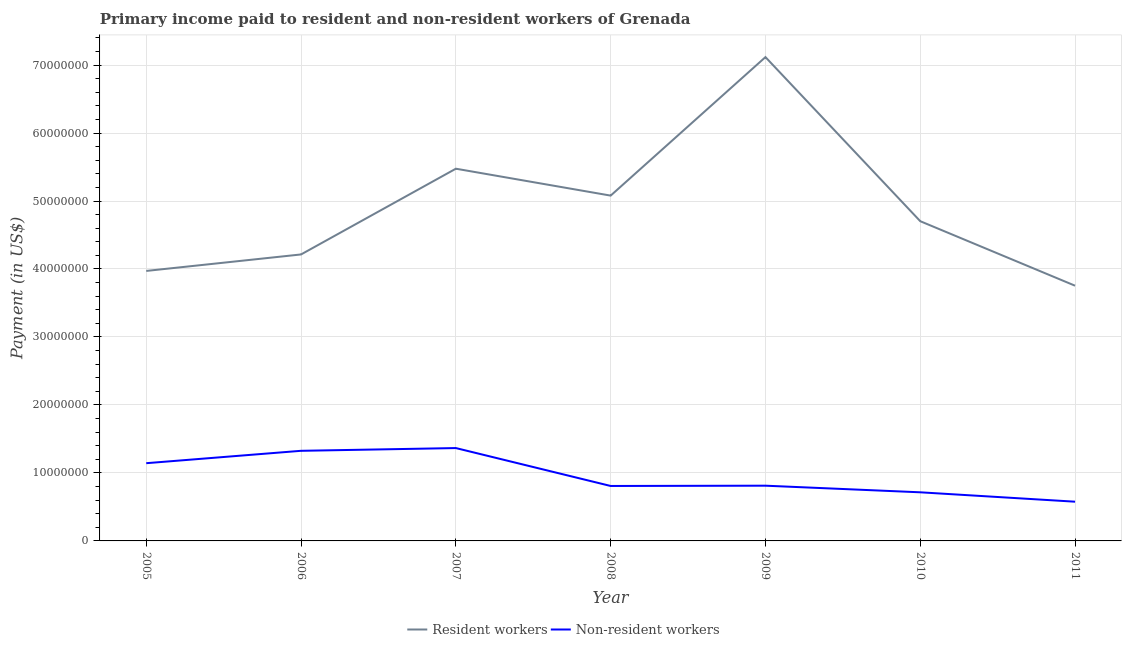Does the line corresponding to payment made to non-resident workers intersect with the line corresponding to payment made to resident workers?
Make the answer very short. No. Is the number of lines equal to the number of legend labels?
Offer a terse response. Yes. What is the payment made to non-resident workers in 2005?
Your answer should be very brief. 1.14e+07. Across all years, what is the maximum payment made to resident workers?
Your answer should be very brief. 7.12e+07. Across all years, what is the minimum payment made to resident workers?
Offer a terse response. 3.75e+07. What is the total payment made to non-resident workers in the graph?
Offer a terse response. 6.75e+07. What is the difference between the payment made to resident workers in 2008 and that in 2011?
Provide a succinct answer. 1.33e+07. What is the difference between the payment made to resident workers in 2010 and the payment made to non-resident workers in 2008?
Ensure brevity in your answer.  3.89e+07. What is the average payment made to resident workers per year?
Make the answer very short. 4.90e+07. In the year 2009, what is the difference between the payment made to non-resident workers and payment made to resident workers?
Offer a terse response. -6.30e+07. What is the ratio of the payment made to resident workers in 2005 to that in 2009?
Provide a succinct answer. 0.56. Is the payment made to resident workers in 2007 less than that in 2008?
Offer a terse response. No. Is the difference between the payment made to non-resident workers in 2010 and 2011 greater than the difference between the payment made to resident workers in 2010 and 2011?
Make the answer very short. No. What is the difference between the highest and the second highest payment made to non-resident workers?
Provide a short and direct response. 4.04e+05. What is the difference between the highest and the lowest payment made to resident workers?
Your answer should be very brief. 3.36e+07. Does the payment made to non-resident workers monotonically increase over the years?
Offer a terse response. No. Is the payment made to non-resident workers strictly greater than the payment made to resident workers over the years?
Your answer should be compact. No. Is the payment made to non-resident workers strictly less than the payment made to resident workers over the years?
Provide a succinct answer. Yes. How many lines are there?
Give a very brief answer. 2. How many years are there in the graph?
Your response must be concise. 7. What is the difference between two consecutive major ticks on the Y-axis?
Provide a short and direct response. 1.00e+07. Where does the legend appear in the graph?
Provide a succinct answer. Bottom center. How many legend labels are there?
Offer a terse response. 2. What is the title of the graph?
Give a very brief answer. Primary income paid to resident and non-resident workers of Grenada. What is the label or title of the X-axis?
Your answer should be very brief. Year. What is the label or title of the Y-axis?
Your response must be concise. Payment (in US$). What is the Payment (in US$) in Resident workers in 2005?
Your response must be concise. 3.97e+07. What is the Payment (in US$) in Non-resident workers in 2005?
Offer a very short reply. 1.14e+07. What is the Payment (in US$) in Resident workers in 2006?
Provide a short and direct response. 4.21e+07. What is the Payment (in US$) in Non-resident workers in 2006?
Offer a very short reply. 1.33e+07. What is the Payment (in US$) in Resident workers in 2007?
Offer a very short reply. 5.48e+07. What is the Payment (in US$) of Non-resident workers in 2007?
Offer a very short reply. 1.37e+07. What is the Payment (in US$) of Resident workers in 2008?
Your response must be concise. 5.08e+07. What is the Payment (in US$) in Non-resident workers in 2008?
Give a very brief answer. 8.08e+06. What is the Payment (in US$) of Resident workers in 2009?
Keep it short and to the point. 7.12e+07. What is the Payment (in US$) in Non-resident workers in 2009?
Your response must be concise. 8.12e+06. What is the Payment (in US$) in Resident workers in 2010?
Make the answer very short. 4.70e+07. What is the Payment (in US$) of Non-resident workers in 2010?
Provide a succinct answer. 7.15e+06. What is the Payment (in US$) in Resident workers in 2011?
Keep it short and to the point. 3.75e+07. What is the Payment (in US$) of Non-resident workers in 2011?
Give a very brief answer. 5.77e+06. Across all years, what is the maximum Payment (in US$) of Resident workers?
Keep it short and to the point. 7.12e+07. Across all years, what is the maximum Payment (in US$) of Non-resident workers?
Your answer should be very brief. 1.37e+07. Across all years, what is the minimum Payment (in US$) in Resident workers?
Provide a succinct answer. 3.75e+07. Across all years, what is the minimum Payment (in US$) of Non-resident workers?
Offer a very short reply. 5.77e+06. What is the total Payment (in US$) in Resident workers in the graph?
Keep it short and to the point. 3.43e+08. What is the total Payment (in US$) in Non-resident workers in the graph?
Offer a very short reply. 6.75e+07. What is the difference between the Payment (in US$) of Resident workers in 2005 and that in 2006?
Ensure brevity in your answer.  -2.42e+06. What is the difference between the Payment (in US$) in Non-resident workers in 2005 and that in 2006?
Provide a succinct answer. -1.82e+06. What is the difference between the Payment (in US$) of Resident workers in 2005 and that in 2007?
Offer a very short reply. -1.50e+07. What is the difference between the Payment (in US$) in Non-resident workers in 2005 and that in 2007?
Offer a very short reply. -2.23e+06. What is the difference between the Payment (in US$) in Resident workers in 2005 and that in 2008?
Keep it short and to the point. -1.11e+07. What is the difference between the Payment (in US$) in Non-resident workers in 2005 and that in 2008?
Your answer should be compact. 3.35e+06. What is the difference between the Payment (in US$) in Resident workers in 2005 and that in 2009?
Your answer should be compact. -3.15e+07. What is the difference between the Payment (in US$) of Non-resident workers in 2005 and that in 2009?
Keep it short and to the point. 3.31e+06. What is the difference between the Payment (in US$) in Resident workers in 2005 and that in 2010?
Your answer should be very brief. -7.31e+06. What is the difference between the Payment (in US$) of Non-resident workers in 2005 and that in 2010?
Your response must be concise. 4.28e+06. What is the difference between the Payment (in US$) in Resident workers in 2005 and that in 2011?
Give a very brief answer. 2.17e+06. What is the difference between the Payment (in US$) in Non-resident workers in 2005 and that in 2011?
Your answer should be very brief. 5.66e+06. What is the difference between the Payment (in US$) in Resident workers in 2006 and that in 2007?
Provide a succinct answer. -1.26e+07. What is the difference between the Payment (in US$) in Non-resident workers in 2006 and that in 2007?
Keep it short and to the point. -4.04e+05. What is the difference between the Payment (in US$) of Resident workers in 2006 and that in 2008?
Provide a short and direct response. -8.65e+06. What is the difference between the Payment (in US$) of Non-resident workers in 2006 and that in 2008?
Keep it short and to the point. 5.17e+06. What is the difference between the Payment (in US$) in Resident workers in 2006 and that in 2009?
Provide a short and direct response. -2.90e+07. What is the difference between the Payment (in US$) of Non-resident workers in 2006 and that in 2009?
Your answer should be compact. 5.13e+06. What is the difference between the Payment (in US$) of Resident workers in 2006 and that in 2010?
Ensure brevity in your answer.  -4.89e+06. What is the difference between the Payment (in US$) in Non-resident workers in 2006 and that in 2010?
Ensure brevity in your answer.  6.10e+06. What is the difference between the Payment (in US$) of Resident workers in 2006 and that in 2011?
Make the answer very short. 4.60e+06. What is the difference between the Payment (in US$) of Non-resident workers in 2006 and that in 2011?
Your answer should be very brief. 7.49e+06. What is the difference between the Payment (in US$) in Resident workers in 2007 and that in 2008?
Provide a short and direct response. 3.96e+06. What is the difference between the Payment (in US$) of Non-resident workers in 2007 and that in 2008?
Your response must be concise. 5.58e+06. What is the difference between the Payment (in US$) in Resident workers in 2007 and that in 2009?
Ensure brevity in your answer.  -1.64e+07. What is the difference between the Payment (in US$) in Non-resident workers in 2007 and that in 2009?
Offer a very short reply. 5.54e+06. What is the difference between the Payment (in US$) in Resident workers in 2007 and that in 2010?
Offer a very short reply. 7.72e+06. What is the difference between the Payment (in US$) in Non-resident workers in 2007 and that in 2010?
Provide a succinct answer. 6.51e+06. What is the difference between the Payment (in US$) in Resident workers in 2007 and that in 2011?
Make the answer very short. 1.72e+07. What is the difference between the Payment (in US$) of Non-resident workers in 2007 and that in 2011?
Provide a succinct answer. 7.89e+06. What is the difference between the Payment (in US$) of Resident workers in 2008 and that in 2009?
Give a very brief answer. -2.04e+07. What is the difference between the Payment (in US$) of Non-resident workers in 2008 and that in 2009?
Provide a succinct answer. -4.16e+04. What is the difference between the Payment (in US$) of Resident workers in 2008 and that in 2010?
Ensure brevity in your answer.  3.77e+06. What is the difference between the Payment (in US$) of Non-resident workers in 2008 and that in 2010?
Provide a short and direct response. 9.31e+05. What is the difference between the Payment (in US$) of Resident workers in 2008 and that in 2011?
Make the answer very short. 1.33e+07. What is the difference between the Payment (in US$) of Non-resident workers in 2008 and that in 2011?
Provide a succinct answer. 2.31e+06. What is the difference between the Payment (in US$) in Resident workers in 2009 and that in 2010?
Make the answer very short. 2.41e+07. What is the difference between the Payment (in US$) in Non-resident workers in 2009 and that in 2010?
Your response must be concise. 9.73e+05. What is the difference between the Payment (in US$) in Resident workers in 2009 and that in 2011?
Give a very brief answer. 3.36e+07. What is the difference between the Payment (in US$) in Non-resident workers in 2009 and that in 2011?
Make the answer very short. 2.35e+06. What is the difference between the Payment (in US$) in Resident workers in 2010 and that in 2011?
Your response must be concise. 9.49e+06. What is the difference between the Payment (in US$) of Non-resident workers in 2010 and that in 2011?
Offer a very short reply. 1.38e+06. What is the difference between the Payment (in US$) of Resident workers in 2005 and the Payment (in US$) of Non-resident workers in 2006?
Your answer should be compact. 2.65e+07. What is the difference between the Payment (in US$) of Resident workers in 2005 and the Payment (in US$) of Non-resident workers in 2007?
Offer a very short reply. 2.61e+07. What is the difference between the Payment (in US$) in Resident workers in 2005 and the Payment (in US$) in Non-resident workers in 2008?
Provide a succinct answer. 3.16e+07. What is the difference between the Payment (in US$) in Resident workers in 2005 and the Payment (in US$) in Non-resident workers in 2009?
Your answer should be very brief. 3.16e+07. What is the difference between the Payment (in US$) of Resident workers in 2005 and the Payment (in US$) of Non-resident workers in 2010?
Ensure brevity in your answer.  3.26e+07. What is the difference between the Payment (in US$) of Resident workers in 2005 and the Payment (in US$) of Non-resident workers in 2011?
Your answer should be very brief. 3.39e+07. What is the difference between the Payment (in US$) in Resident workers in 2006 and the Payment (in US$) in Non-resident workers in 2007?
Your response must be concise. 2.85e+07. What is the difference between the Payment (in US$) in Resident workers in 2006 and the Payment (in US$) in Non-resident workers in 2008?
Keep it short and to the point. 3.41e+07. What is the difference between the Payment (in US$) of Resident workers in 2006 and the Payment (in US$) of Non-resident workers in 2009?
Offer a very short reply. 3.40e+07. What is the difference between the Payment (in US$) in Resident workers in 2006 and the Payment (in US$) in Non-resident workers in 2010?
Your answer should be compact. 3.50e+07. What is the difference between the Payment (in US$) of Resident workers in 2006 and the Payment (in US$) of Non-resident workers in 2011?
Ensure brevity in your answer.  3.64e+07. What is the difference between the Payment (in US$) of Resident workers in 2007 and the Payment (in US$) of Non-resident workers in 2008?
Your answer should be very brief. 4.67e+07. What is the difference between the Payment (in US$) of Resident workers in 2007 and the Payment (in US$) of Non-resident workers in 2009?
Keep it short and to the point. 4.66e+07. What is the difference between the Payment (in US$) in Resident workers in 2007 and the Payment (in US$) in Non-resident workers in 2010?
Ensure brevity in your answer.  4.76e+07. What is the difference between the Payment (in US$) in Resident workers in 2007 and the Payment (in US$) in Non-resident workers in 2011?
Give a very brief answer. 4.90e+07. What is the difference between the Payment (in US$) of Resident workers in 2008 and the Payment (in US$) of Non-resident workers in 2009?
Your answer should be compact. 4.27e+07. What is the difference between the Payment (in US$) of Resident workers in 2008 and the Payment (in US$) of Non-resident workers in 2010?
Provide a short and direct response. 4.36e+07. What is the difference between the Payment (in US$) of Resident workers in 2008 and the Payment (in US$) of Non-resident workers in 2011?
Keep it short and to the point. 4.50e+07. What is the difference between the Payment (in US$) of Resident workers in 2009 and the Payment (in US$) of Non-resident workers in 2010?
Your answer should be compact. 6.40e+07. What is the difference between the Payment (in US$) in Resident workers in 2009 and the Payment (in US$) in Non-resident workers in 2011?
Ensure brevity in your answer.  6.54e+07. What is the difference between the Payment (in US$) in Resident workers in 2010 and the Payment (in US$) in Non-resident workers in 2011?
Offer a very short reply. 4.13e+07. What is the average Payment (in US$) in Resident workers per year?
Make the answer very short. 4.90e+07. What is the average Payment (in US$) of Non-resident workers per year?
Ensure brevity in your answer.  9.64e+06. In the year 2005, what is the difference between the Payment (in US$) in Resident workers and Payment (in US$) in Non-resident workers?
Offer a very short reply. 2.83e+07. In the year 2006, what is the difference between the Payment (in US$) in Resident workers and Payment (in US$) in Non-resident workers?
Give a very brief answer. 2.89e+07. In the year 2007, what is the difference between the Payment (in US$) in Resident workers and Payment (in US$) in Non-resident workers?
Offer a very short reply. 4.11e+07. In the year 2008, what is the difference between the Payment (in US$) of Resident workers and Payment (in US$) of Non-resident workers?
Ensure brevity in your answer.  4.27e+07. In the year 2009, what is the difference between the Payment (in US$) in Resident workers and Payment (in US$) in Non-resident workers?
Ensure brevity in your answer.  6.30e+07. In the year 2010, what is the difference between the Payment (in US$) of Resident workers and Payment (in US$) of Non-resident workers?
Provide a short and direct response. 3.99e+07. In the year 2011, what is the difference between the Payment (in US$) in Resident workers and Payment (in US$) in Non-resident workers?
Provide a succinct answer. 3.18e+07. What is the ratio of the Payment (in US$) of Resident workers in 2005 to that in 2006?
Make the answer very short. 0.94. What is the ratio of the Payment (in US$) of Non-resident workers in 2005 to that in 2006?
Your answer should be very brief. 0.86. What is the ratio of the Payment (in US$) of Resident workers in 2005 to that in 2007?
Your answer should be very brief. 0.73. What is the ratio of the Payment (in US$) in Non-resident workers in 2005 to that in 2007?
Offer a terse response. 0.84. What is the ratio of the Payment (in US$) of Resident workers in 2005 to that in 2008?
Your response must be concise. 0.78. What is the ratio of the Payment (in US$) of Non-resident workers in 2005 to that in 2008?
Give a very brief answer. 1.41. What is the ratio of the Payment (in US$) of Resident workers in 2005 to that in 2009?
Your answer should be very brief. 0.56. What is the ratio of the Payment (in US$) of Non-resident workers in 2005 to that in 2009?
Offer a terse response. 1.41. What is the ratio of the Payment (in US$) in Resident workers in 2005 to that in 2010?
Offer a terse response. 0.84. What is the ratio of the Payment (in US$) of Non-resident workers in 2005 to that in 2010?
Keep it short and to the point. 1.6. What is the ratio of the Payment (in US$) of Resident workers in 2005 to that in 2011?
Ensure brevity in your answer.  1.06. What is the ratio of the Payment (in US$) of Non-resident workers in 2005 to that in 2011?
Your answer should be compact. 1.98. What is the ratio of the Payment (in US$) in Resident workers in 2006 to that in 2007?
Keep it short and to the point. 0.77. What is the ratio of the Payment (in US$) in Non-resident workers in 2006 to that in 2007?
Provide a short and direct response. 0.97. What is the ratio of the Payment (in US$) in Resident workers in 2006 to that in 2008?
Provide a succinct answer. 0.83. What is the ratio of the Payment (in US$) of Non-resident workers in 2006 to that in 2008?
Your response must be concise. 1.64. What is the ratio of the Payment (in US$) in Resident workers in 2006 to that in 2009?
Your response must be concise. 0.59. What is the ratio of the Payment (in US$) of Non-resident workers in 2006 to that in 2009?
Your answer should be very brief. 1.63. What is the ratio of the Payment (in US$) of Resident workers in 2006 to that in 2010?
Keep it short and to the point. 0.9. What is the ratio of the Payment (in US$) in Non-resident workers in 2006 to that in 2010?
Keep it short and to the point. 1.85. What is the ratio of the Payment (in US$) of Resident workers in 2006 to that in 2011?
Your answer should be very brief. 1.12. What is the ratio of the Payment (in US$) in Non-resident workers in 2006 to that in 2011?
Give a very brief answer. 2.3. What is the ratio of the Payment (in US$) in Resident workers in 2007 to that in 2008?
Provide a short and direct response. 1.08. What is the ratio of the Payment (in US$) of Non-resident workers in 2007 to that in 2008?
Your response must be concise. 1.69. What is the ratio of the Payment (in US$) of Resident workers in 2007 to that in 2009?
Give a very brief answer. 0.77. What is the ratio of the Payment (in US$) of Non-resident workers in 2007 to that in 2009?
Provide a short and direct response. 1.68. What is the ratio of the Payment (in US$) in Resident workers in 2007 to that in 2010?
Offer a very short reply. 1.16. What is the ratio of the Payment (in US$) of Non-resident workers in 2007 to that in 2010?
Ensure brevity in your answer.  1.91. What is the ratio of the Payment (in US$) in Resident workers in 2007 to that in 2011?
Your answer should be compact. 1.46. What is the ratio of the Payment (in US$) in Non-resident workers in 2007 to that in 2011?
Your response must be concise. 2.37. What is the ratio of the Payment (in US$) in Resident workers in 2008 to that in 2009?
Offer a terse response. 0.71. What is the ratio of the Payment (in US$) of Resident workers in 2008 to that in 2010?
Keep it short and to the point. 1.08. What is the ratio of the Payment (in US$) in Non-resident workers in 2008 to that in 2010?
Ensure brevity in your answer.  1.13. What is the ratio of the Payment (in US$) of Resident workers in 2008 to that in 2011?
Ensure brevity in your answer.  1.35. What is the ratio of the Payment (in US$) in Non-resident workers in 2008 to that in 2011?
Your answer should be compact. 1.4. What is the ratio of the Payment (in US$) in Resident workers in 2009 to that in 2010?
Provide a short and direct response. 1.51. What is the ratio of the Payment (in US$) of Non-resident workers in 2009 to that in 2010?
Your answer should be very brief. 1.14. What is the ratio of the Payment (in US$) in Resident workers in 2009 to that in 2011?
Ensure brevity in your answer.  1.9. What is the ratio of the Payment (in US$) of Non-resident workers in 2009 to that in 2011?
Ensure brevity in your answer.  1.41. What is the ratio of the Payment (in US$) of Resident workers in 2010 to that in 2011?
Offer a terse response. 1.25. What is the ratio of the Payment (in US$) of Non-resident workers in 2010 to that in 2011?
Your answer should be very brief. 1.24. What is the difference between the highest and the second highest Payment (in US$) in Resident workers?
Give a very brief answer. 1.64e+07. What is the difference between the highest and the second highest Payment (in US$) of Non-resident workers?
Your response must be concise. 4.04e+05. What is the difference between the highest and the lowest Payment (in US$) of Resident workers?
Provide a short and direct response. 3.36e+07. What is the difference between the highest and the lowest Payment (in US$) of Non-resident workers?
Make the answer very short. 7.89e+06. 